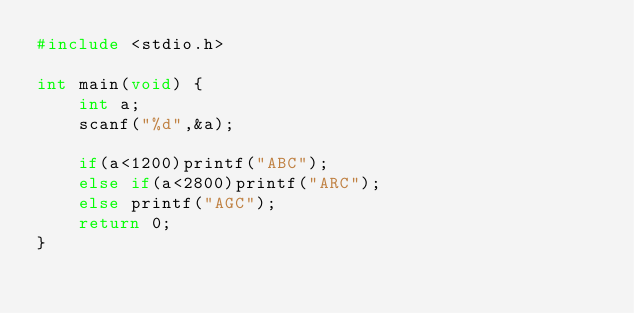Convert code to text. <code><loc_0><loc_0><loc_500><loc_500><_C_>#include <stdio.h>

int main(void) {
	int a;
	scanf("%d",&a);
	
	if(a<1200)printf("ABC");
	else if(a<2800)printf("ARC");
	else printf("AGC");
	return 0;
}</code> 